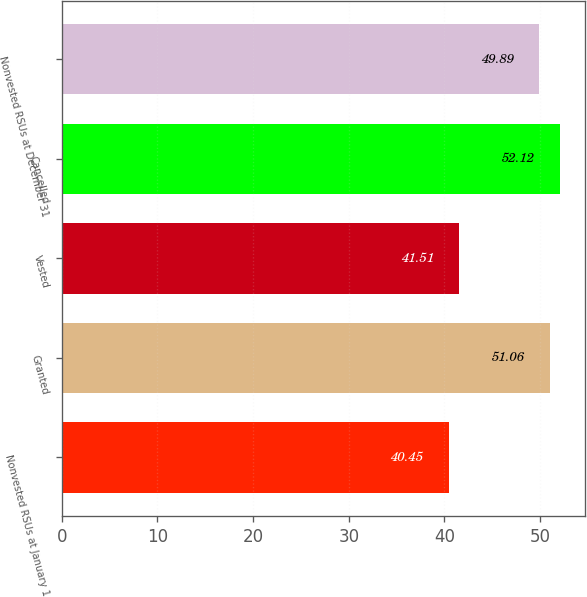<chart> <loc_0><loc_0><loc_500><loc_500><bar_chart><fcel>Nonvested RSUs at January 1<fcel>Granted<fcel>Vested<fcel>Cancelled<fcel>Nonvested RSUs at December 31<nl><fcel>40.45<fcel>51.06<fcel>41.51<fcel>52.12<fcel>49.89<nl></chart> 